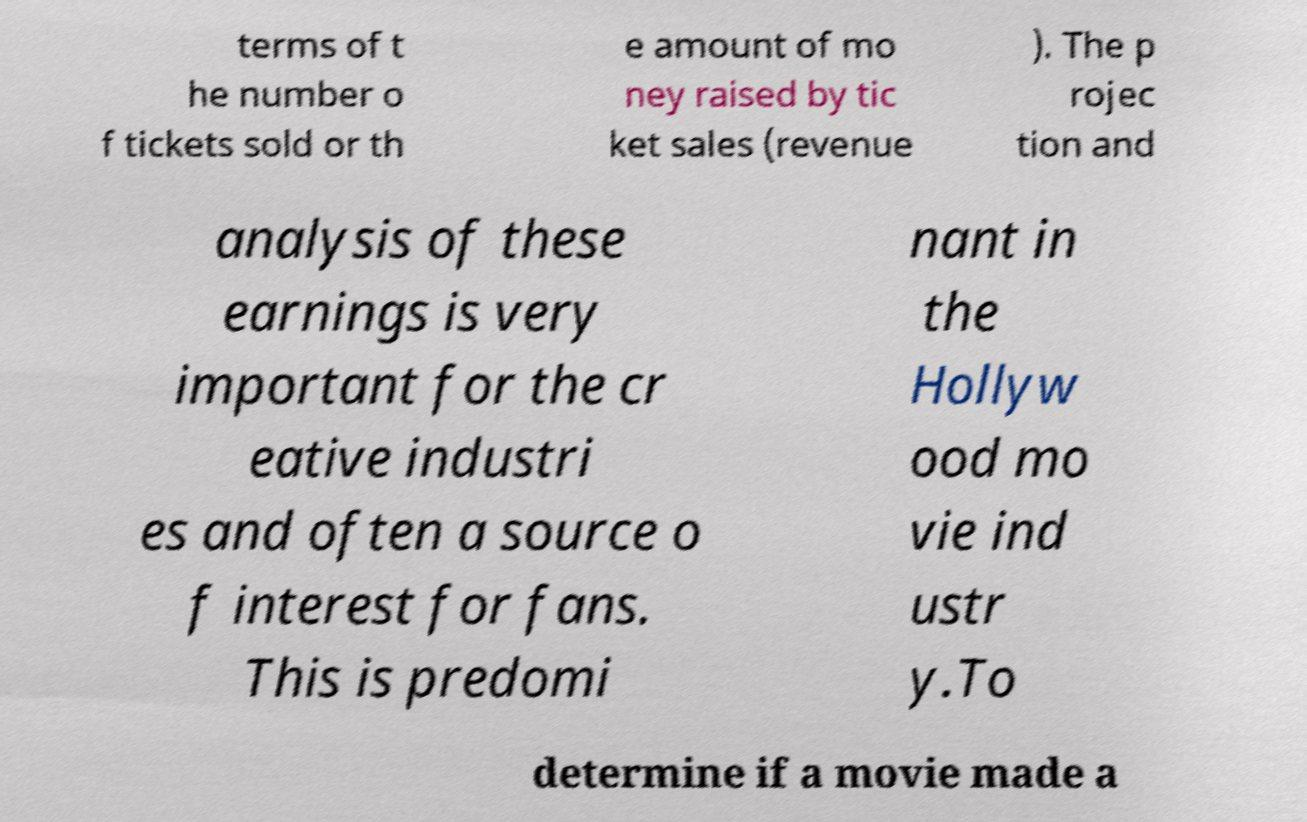I need the written content from this picture converted into text. Can you do that? terms of t he number o f tickets sold or th e amount of mo ney raised by tic ket sales (revenue ). The p rojec tion and analysis of these earnings is very important for the cr eative industri es and often a source o f interest for fans. This is predomi nant in the Hollyw ood mo vie ind ustr y.To determine if a movie made a 